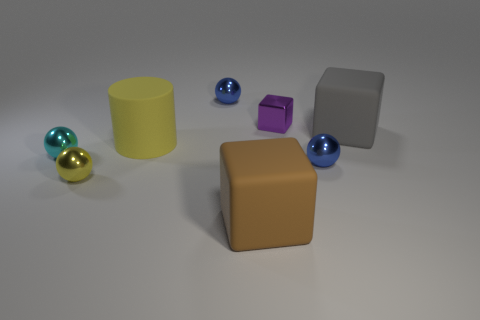Subtract 1 spheres. How many spheres are left? 3 Add 1 big brown matte spheres. How many objects exist? 9 Subtract all blocks. How many objects are left? 5 Add 1 tiny cyan objects. How many tiny cyan objects are left? 2 Add 3 small cyan matte cylinders. How many small cyan matte cylinders exist? 3 Subtract 2 blue balls. How many objects are left? 6 Subtract all big metal cylinders. Subtract all small metal objects. How many objects are left? 3 